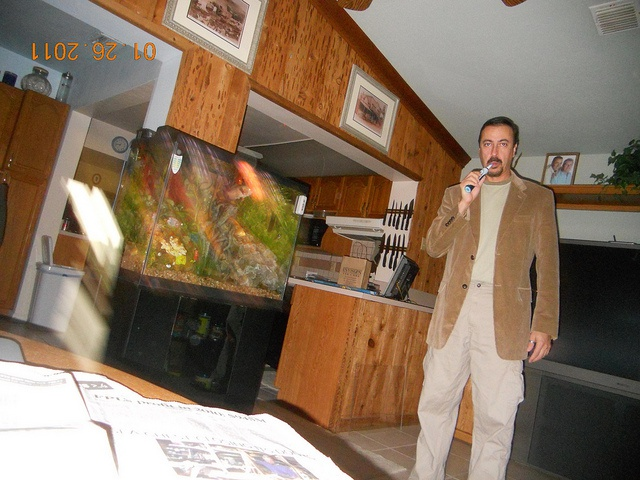Describe the objects in this image and their specific colors. I can see people in purple, gray, lightgray, and tan tones, tv in purple, black, and gray tones, potted plant in purple, black, gray, maroon, and olive tones, microwave in purple, black, maroon, and gray tones, and clock in black and gray tones in this image. 